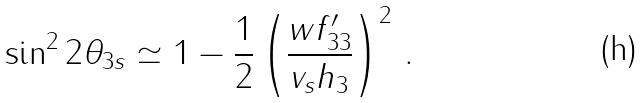<formula> <loc_0><loc_0><loc_500><loc_500>\sin ^ { 2 } 2 \theta _ { 3 s } \simeq 1 - \frac { 1 } { 2 } \left ( \frac { w f _ { 3 3 } ^ { \prime } } { v _ { s } h _ { 3 } } \right ) ^ { 2 } \, .</formula> 